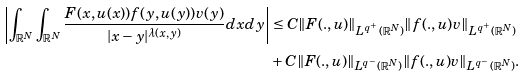Convert formula to latex. <formula><loc_0><loc_0><loc_500><loc_500>\left | \int _ { \mathbb { R } ^ { N } } \int _ { \mathbb { R } ^ { N } } \frac { F ( x , u ( x ) ) f ( y , u ( y ) ) v ( y ) } { | x - y | ^ { \lambda ( x , y ) } } d x d y \right | & \leq C \| F ( . , u ) \| _ { L ^ { q ^ { + } } ( \mathbb { R } ^ { N } ) } \| f ( . , u ) v \| _ { L ^ { q ^ { + } } ( \mathbb { R } ^ { N } ) } \\ & + C \| F ( . , u ) \| _ { L ^ { q ^ { - } } ( \mathbb { R } ^ { N } ) } \| f ( . , u ) v \| _ { L ^ { q ^ { - } } ( \mathbb { R } ^ { N } ) } .</formula> 